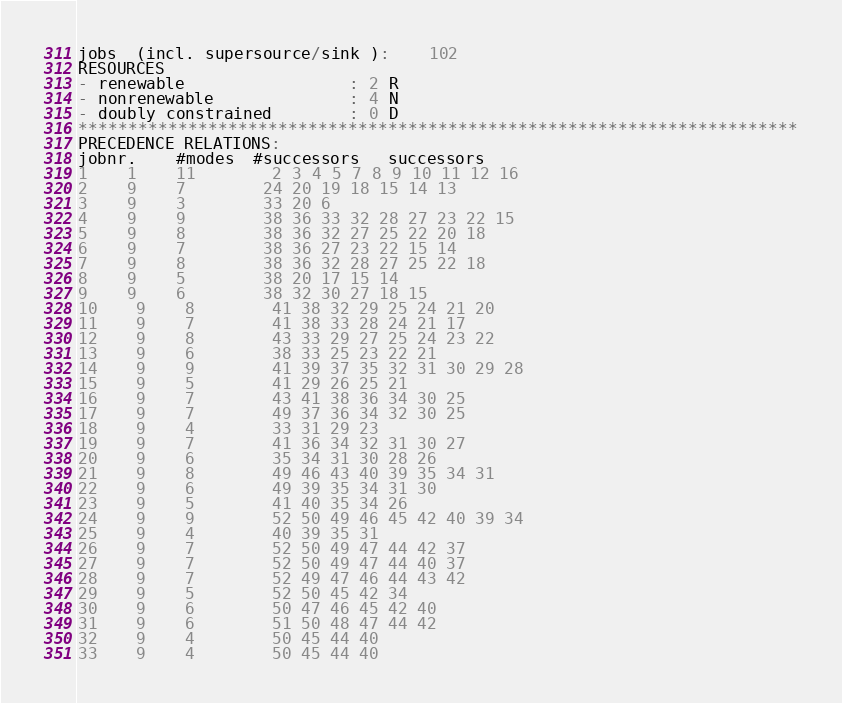Convert code to text. <code><loc_0><loc_0><loc_500><loc_500><_ObjectiveC_>jobs  (incl. supersource/sink ):	102
RESOURCES
- renewable                 : 2 R
- nonrenewable              : 4 N
- doubly constrained        : 0 D
************************************************************************
PRECEDENCE RELATIONS:
jobnr.    #modes  #successors   successors
1	1	11		2 3 4 5 7 8 9 10 11 12 16 
2	9	7		24 20 19 18 15 14 13 
3	9	3		33 20 6 
4	9	9		38 36 33 32 28 27 23 22 15 
5	9	8		38 36 32 27 25 22 20 18 
6	9	7		38 36 27 23 22 15 14 
7	9	8		38 36 32 28 27 25 22 18 
8	9	5		38 20 17 15 14 
9	9	6		38 32 30 27 18 15 
10	9	8		41 38 32 29 25 24 21 20 
11	9	7		41 38 33 28 24 21 17 
12	9	8		43 33 29 27 25 24 23 22 
13	9	6		38 33 25 23 22 21 
14	9	9		41 39 37 35 32 31 30 29 28 
15	9	5		41 29 26 25 21 
16	9	7		43 41 38 36 34 30 25 
17	9	7		49 37 36 34 32 30 25 
18	9	4		33 31 29 23 
19	9	7		41 36 34 32 31 30 27 
20	9	6		35 34 31 30 28 26 
21	9	8		49 46 43 40 39 35 34 31 
22	9	6		49 39 35 34 31 30 
23	9	5		41 40 35 34 26 
24	9	9		52 50 49 46 45 42 40 39 34 
25	9	4		40 39 35 31 
26	9	7		52 50 49 47 44 42 37 
27	9	7		52 50 49 47 44 40 37 
28	9	7		52 49 47 46 44 43 42 
29	9	5		52 50 45 42 34 
30	9	6		50 47 46 45 42 40 
31	9	6		51 50 48 47 44 42 
32	9	4		50 45 44 40 
33	9	4		50 45 44 40 </code> 